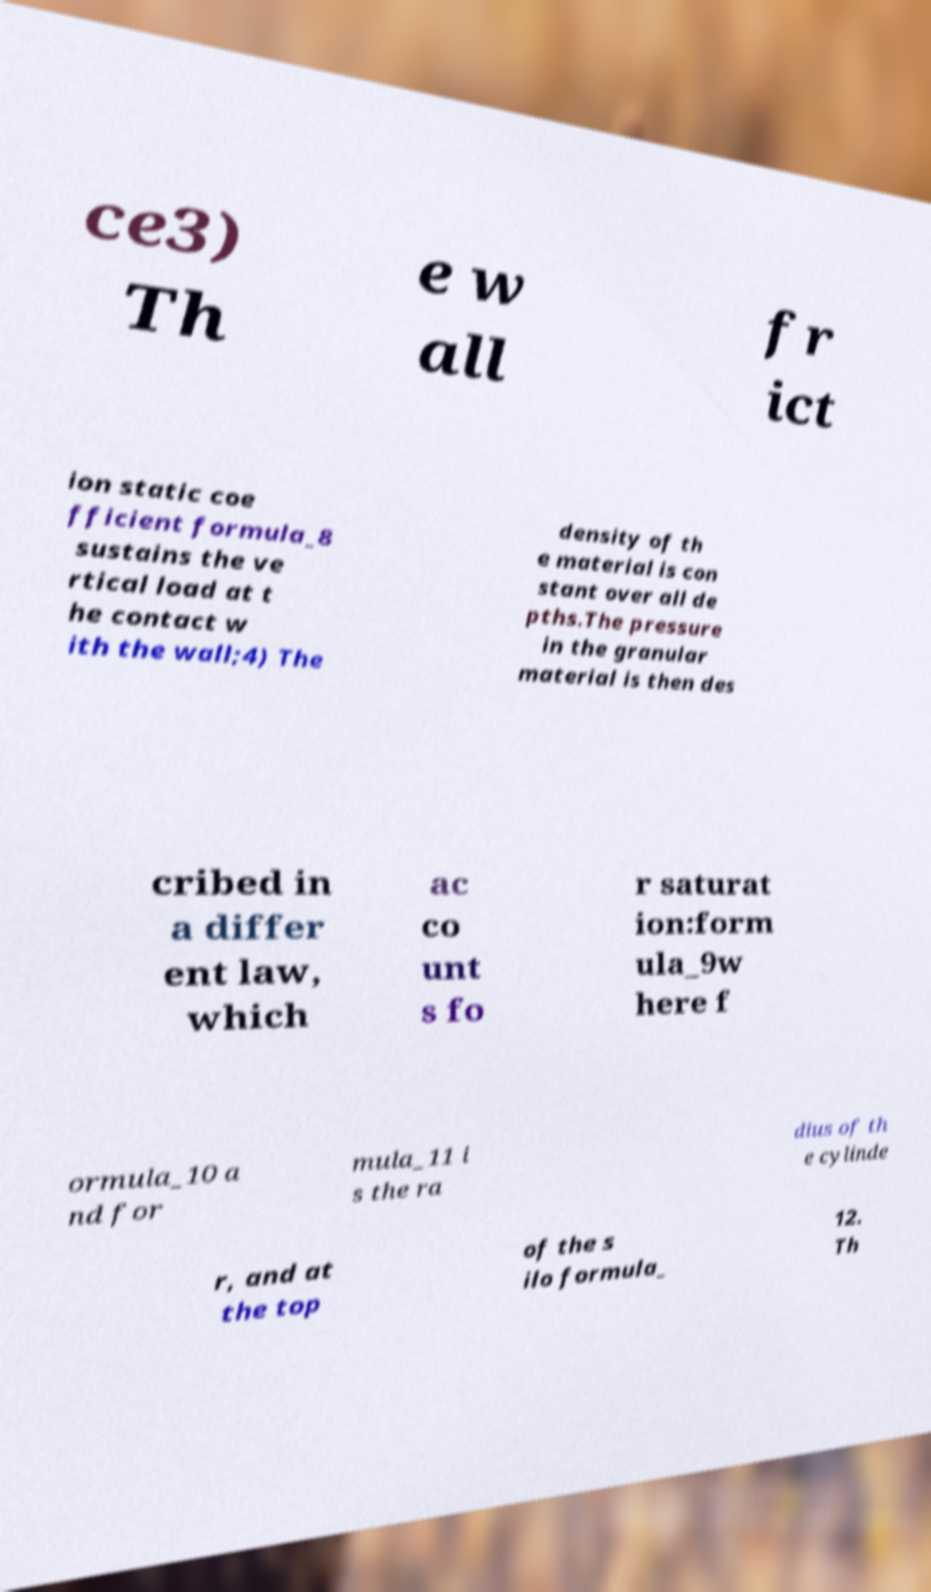Can you read and provide the text displayed in the image?This photo seems to have some interesting text. Can you extract and type it out for me? ce3) Th e w all fr ict ion static coe fficient formula_8 sustains the ve rtical load at t he contact w ith the wall;4) The density of th e material is con stant over all de pths.The pressure in the granular material is then des cribed in a differ ent law, which ac co unt s fo r saturat ion:form ula_9w here f ormula_10 a nd for mula_11 i s the ra dius of th e cylinde r, and at the top of the s ilo formula_ 12. Th 